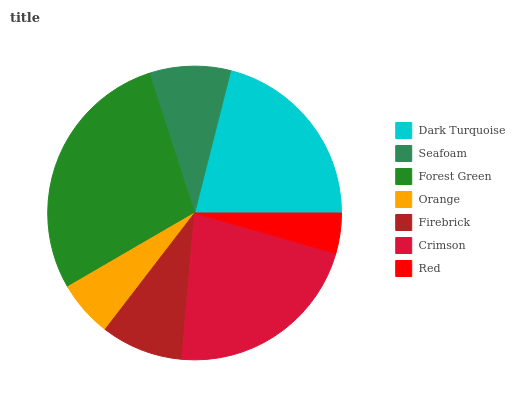Is Red the minimum?
Answer yes or no. Yes. Is Forest Green the maximum?
Answer yes or no. Yes. Is Seafoam the minimum?
Answer yes or no. No. Is Seafoam the maximum?
Answer yes or no. No. Is Dark Turquoise greater than Seafoam?
Answer yes or no. Yes. Is Seafoam less than Dark Turquoise?
Answer yes or no. Yes. Is Seafoam greater than Dark Turquoise?
Answer yes or no. No. Is Dark Turquoise less than Seafoam?
Answer yes or no. No. Is Firebrick the high median?
Answer yes or no. Yes. Is Firebrick the low median?
Answer yes or no. Yes. Is Crimson the high median?
Answer yes or no. No. Is Red the low median?
Answer yes or no. No. 